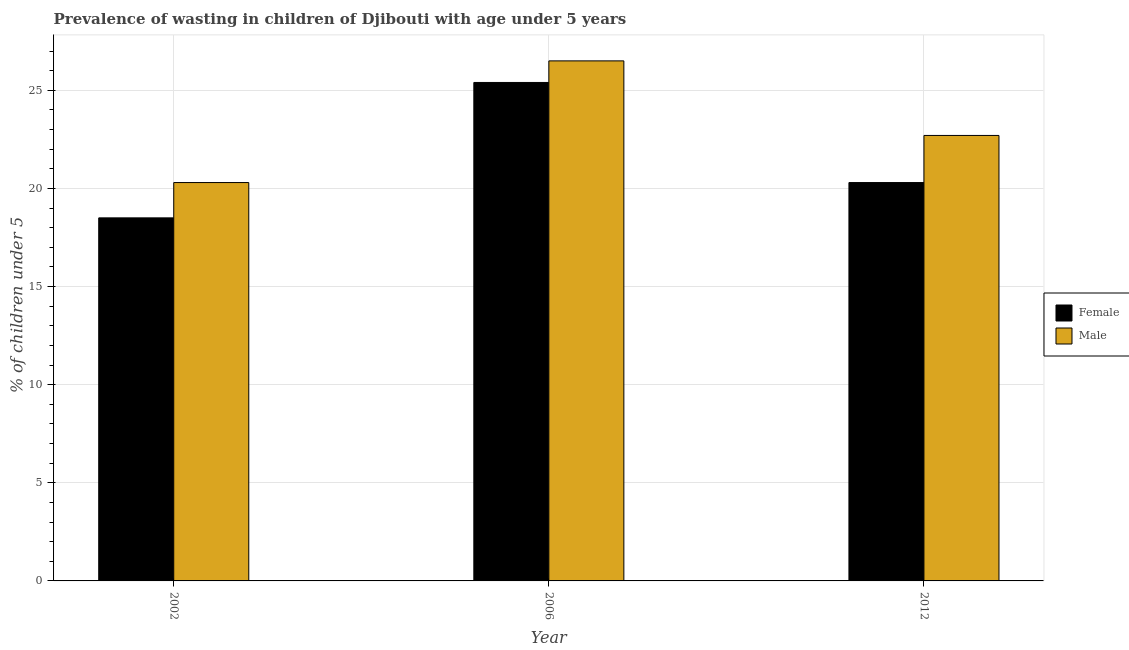How many different coloured bars are there?
Make the answer very short. 2. How many groups of bars are there?
Keep it short and to the point. 3. How many bars are there on the 2nd tick from the right?
Make the answer very short. 2. Across all years, what is the maximum percentage of undernourished male children?
Provide a succinct answer. 26.5. Across all years, what is the minimum percentage of undernourished male children?
Offer a very short reply. 20.3. What is the total percentage of undernourished female children in the graph?
Make the answer very short. 64.2. What is the difference between the percentage of undernourished male children in 2002 and that in 2006?
Offer a very short reply. -6.2. What is the difference between the percentage of undernourished female children in 2006 and the percentage of undernourished male children in 2002?
Make the answer very short. 6.9. What is the average percentage of undernourished male children per year?
Your answer should be very brief. 23.17. What is the ratio of the percentage of undernourished male children in 2006 to that in 2012?
Provide a succinct answer. 1.17. Is the percentage of undernourished male children in 2002 less than that in 2006?
Your answer should be very brief. Yes. What is the difference between the highest and the second highest percentage of undernourished male children?
Your response must be concise. 3.8. What is the difference between the highest and the lowest percentage of undernourished male children?
Your answer should be compact. 6.2. In how many years, is the percentage of undernourished male children greater than the average percentage of undernourished male children taken over all years?
Your response must be concise. 1. Is the sum of the percentage of undernourished female children in 2006 and 2012 greater than the maximum percentage of undernourished male children across all years?
Offer a terse response. Yes. What does the 2nd bar from the right in 2002 represents?
Ensure brevity in your answer.  Female. Are all the bars in the graph horizontal?
Provide a succinct answer. No. How many years are there in the graph?
Ensure brevity in your answer.  3. Does the graph contain any zero values?
Ensure brevity in your answer.  No. Where does the legend appear in the graph?
Keep it short and to the point. Center right. How are the legend labels stacked?
Your response must be concise. Vertical. What is the title of the graph?
Offer a very short reply. Prevalence of wasting in children of Djibouti with age under 5 years. What is the label or title of the X-axis?
Your response must be concise. Year. What is the label or title of the Y-axis?
Offer a terse response.  % of children under 5. What is the  % of children under 5 of Male in 2002?
Offer a terse response. 20.3. What is the  % of children under 5 of Female in 2006?
Offer a terse response. 25.4. What is the  % of children under 5 in Female in 2012?
Give a very brief answer. 20.3. What is the  % of children under 5 of Male in 2012?
Make the answer very short. 22.7. Across all years, what is the maximum  % of children under 5 of Female?
Provide a succinct answer. 25.4. Across all years, what is the minimum  % of children under 5 of Male?
Keep it short and to the point. 20.3. What is the total  % of children under 5 in Female in the graph?
Give a very brief answer. 64.2. What is the total  % of children under 5 of Male in the graph?
Offer a very short reply. 69.5. What is the difference between the  % of children under 5 in Male in 2002 and that in 2006?
Provide a succinct answer. -6.2. What is the difference between the  % of children under 5 in Female in 2002 and that in 2012?
Your answer should be compact. -1.8. What is the difference between the  % of children under 5 of Male in 2006 and that in 2012?
Your response must be concise. 3.8. What is the difference between the  % of children under 5 in Female in 2006 and the  % of children under 5 in Male in 2012?
Provide a short and direct response. 2.7. What is the average  % of children under 5 of Female per year?
Ensure brevity in your answer.  21.4. What is the average  % of children under 5 of Male per year?
Your response must be concise. 23.17. In the year 2006, what is the difference between the  % of children under 5 of Female and  % of children under 5 of Male?
Offer a terse response. -1.1. In the year 2012, what is the difference between the  % of children under 5 in Female and  % of children under 5 in Male?
Your response must be concise. -2.4. What is the ratio of the  % of children under 5 in Female in 2002 to that in 2006?
Provide a succinct answer. 0.73. What is the ratio of the  % of children under 5 of Male in 2002 to that in 2006?
Provide a succinct answer. 0.77. What is the ratio of the  % of children under 5 of Female in 2002 to that in 2012?
Offer a very short reply. 0.91. What is the ratio of the  % of children under 5 in Male in 2002 to that in 2012?
Provide a short and direct response. 0.89. What is the ratio of the  % of children under 5 in Female in 2006 to that in 2012?
Provide a short and direct response. 1.25. What is the ratio of the  % of children under 5 in Male in 2006 to that in 2012?
Make the answer very short. 1.17. What is the difference between the highest and the lowest  % of children under 5 in Female?
Give a very brief answer. 6.9. 